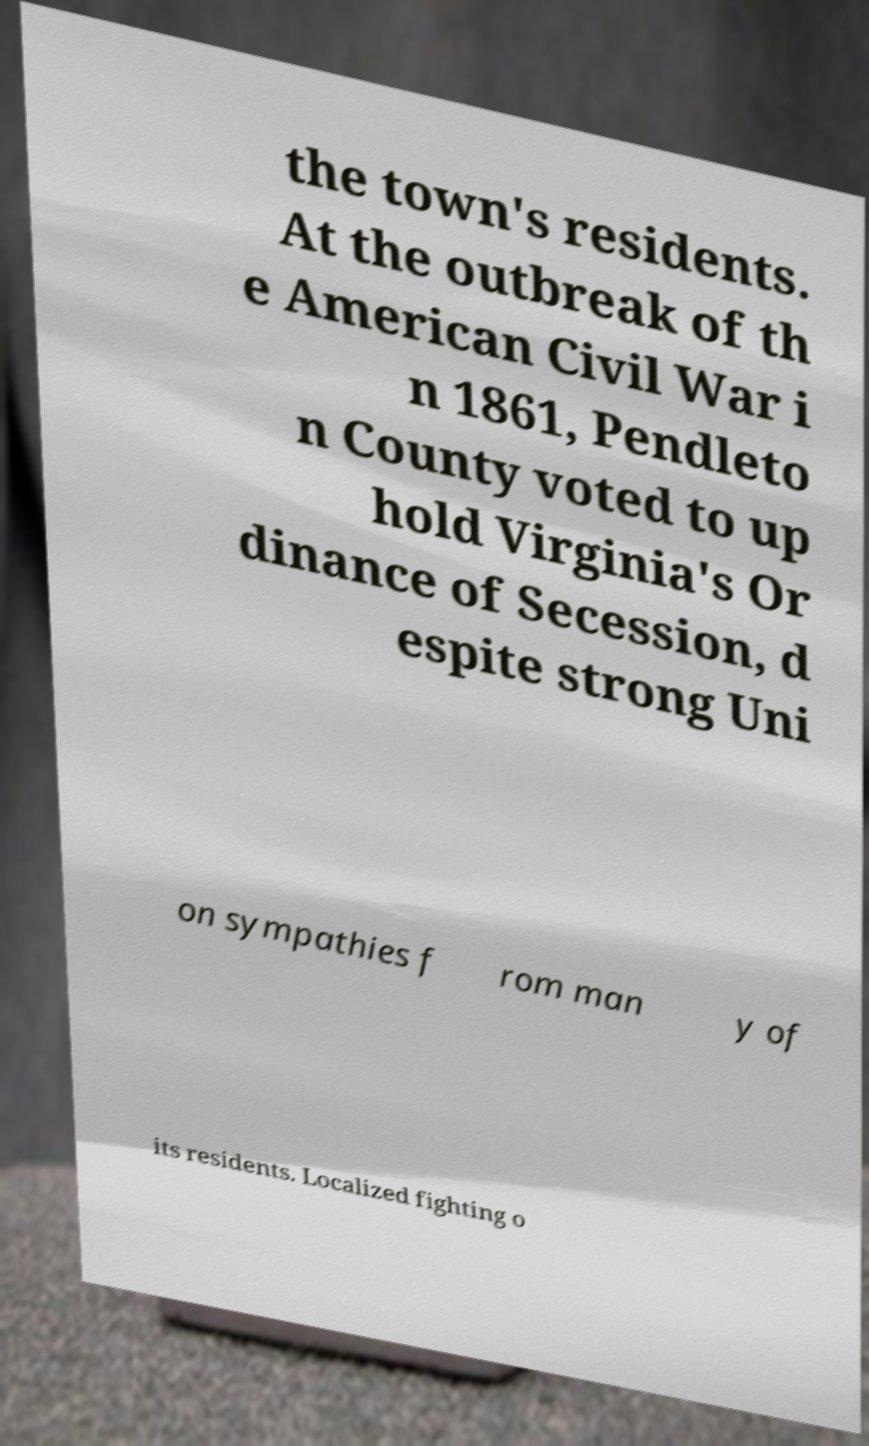What messages or text are displayed in this image? I need them in a readable, typed format. the town's residents. At the outbreak of th e American Civil War i n 1861, Pendleto n County voted to up hold Virginia's Or dinance of Secession, d espite strong Uni on sympathies f rom man y of its residents. Localized fighting o 